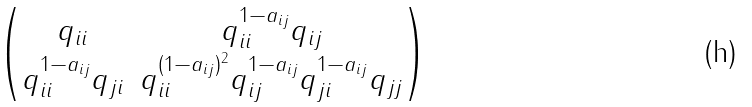Convert formula to latex. <formula><loc_0><loc_0><loc_500><loc_500>\begin{pmatrix} q _ { i i } & q _ { i i } ^ { 1 - a _ { i j } } q _ { i j } \\ q _ { i i } ^ { 1 - a _ { i j } } q _ { j i } & q _ { i i } ^ { ( 1 - a _ { i j } ) ^ { 2 } } q _ { i j } ^ { 1 - a _ { i j } } q _ { j i } ^ { 1 - a _ { i j } } q _ { j j } \end{pmatrix}</formula> 